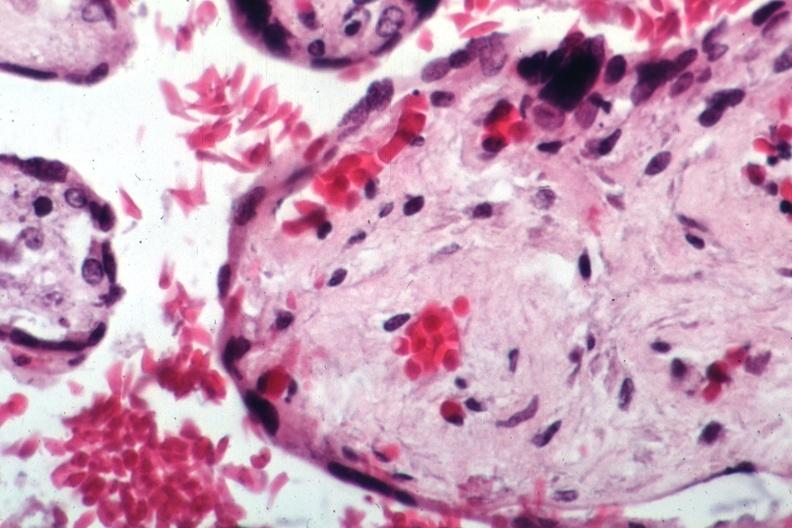s female reproductive present?
Answer the question using a single word or phrase. Yes 